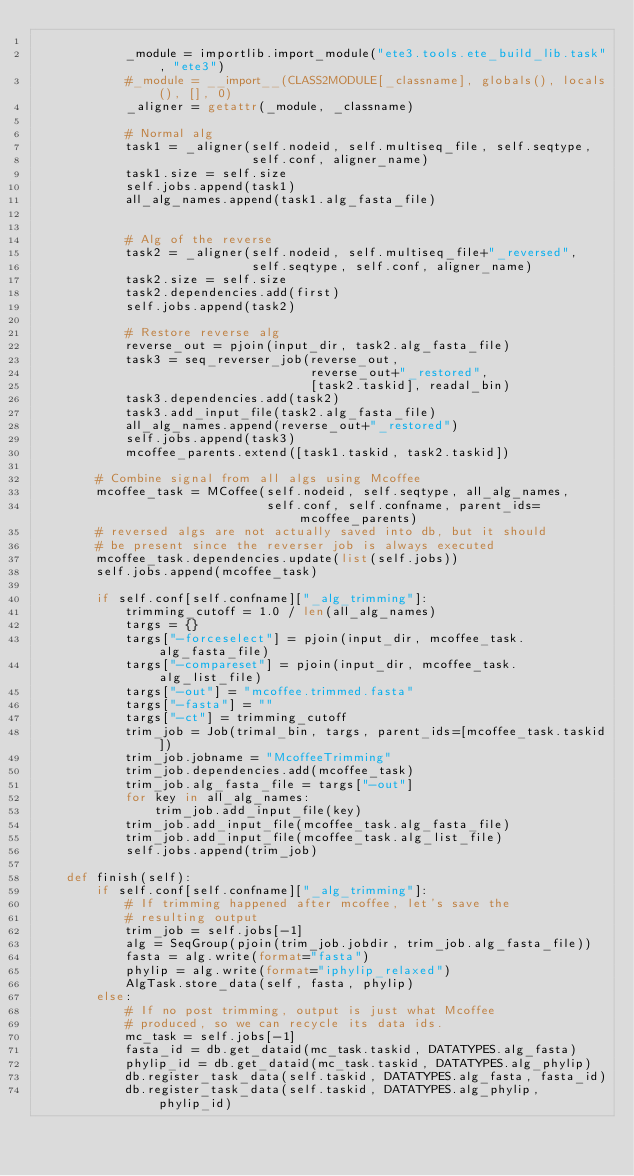Convert code to text. <code><loc_0><loc_0><loc_500><loc_500><_Python_>
            _module = importlib.import_module("ete3.tools.ete_build_lib.task", "ete3")
            #_module = __import__(CLASS2MODULE[_classname], globals(), locals(), [], 0)
            _aligner = getattr(_module, _classname)

            # Normal alg
            task1 = _aligner(self.nodeid, self.multiseq_file, self.seqtype,
                             self.conf, aligner_name)
            task1.size = self.size
            self.jobs.append(task1)
            all_alg_names.append(task1.alg_fasta_file)


            # Alg of the reverse
            task2 = _aligner(self.nodeid, self.multiseq_file+"_reversed",
                             self.seqtype, self.conf, aligner_name)
            task2.size = self.size
            task2.dependencies.add(first)
            self.jobs.append(task2)

            # Restore reverse alg
            reverse_out = pjoin(input_dir, task2.alg_fasta_file)
            task3 = seq_reverser_job(reverse_out,
                                     reverse_out+"_restored",
                                     [task2.taskid], readal_bin)
            task3.dependencies.add(task2)
            task3.add_input_file(task2.alg_fasta_file)
            all_alg_names.append(reverse_out+"_restored")
            self.jobs.append(task3)
            mcoffee_parents.extend([task1.taskid, task2.taskid])

        # Combine signal from all algs using Mcoffee
        mcoffee_task = MCoffee(self.nodeid, self.seqtype, all_alg_names,
                               self.conf, self.confname, parent_ids=mcoffee_parents)
        # reversed algs are not actually saved into db, but it should
        # be present since the reverser job is always executed
        mcoffee_task.dependencies.update(list(self.jobs))
        self.jobs.append(mcoffee_task)

        if self.conf[self.confname]["_alg_trimming"]:
            trimming_cutoff = 1.0 / len(all_alg_names)
            targs = {}
            targs["-forceselect"] = pjoin(input_dir, mcoffee_task.alg_fasta_file)
            targs["-compareset"] = pjoin(input_dir, mcoffee_task.alg_list_file)
            targs["-out"] = "mcoffee.trimmed.fasta"
            targs["-fasta"] = ""
            targs["-ct"] = trimming_cutoff
            trim_job = Job(trimal_bin, targs, parent_ids=[mcoffee_task.taskid])
            trim_job.jobname = "McoffeeTrimming"
            trim_job.dependencies.add(mcoffee_task)
            trim_job.alg_fasta_file = targs["-out"]
            for key in all_alg_names:
                trim_job.add_input_file(key)
            trim_job.add_input_file(mcoffee_task.alg_fasta_file)
            trim_job.add_input_file(mcoffee_task.alg_list_file)
            self.jobs.append(trim_job)

    def finish(self):
        if self.conf[self.confname]["_alg_trimming"]:
            # If trimming happened after mcoffee, let's save the
            # resulting output
            trim_job = self.jobs[-1]
            alg = SeqGroup(pjoin(trim_job.jobdir, trim_job.alg_fasta_file))
            fasta = alg.write(format="fasta")
            phylip = alg.write(format="iphylip_relaxed")
            AlgTask.store_data(self, fasta, phylip)
        else:
            # If no post trimming, output is just what Mcoffee
            # produced, so we can recycle its data ids.
            mc_task = self.jobs[-1]
            fasta_id = db.get_dataid(mc_task.taskid, DATATYPES.alg_fasta)
            phylip_id = db.get_dataid(mc_task.taskid, DATATYPES.alg_phylip)
            db.register_task_data(self.taskid, DATATYPES.alg_fasta, fasta_id)
            db.register_task_data(self.taskid, DATATYPES.alg_phylip, phylip_id)
</code> 